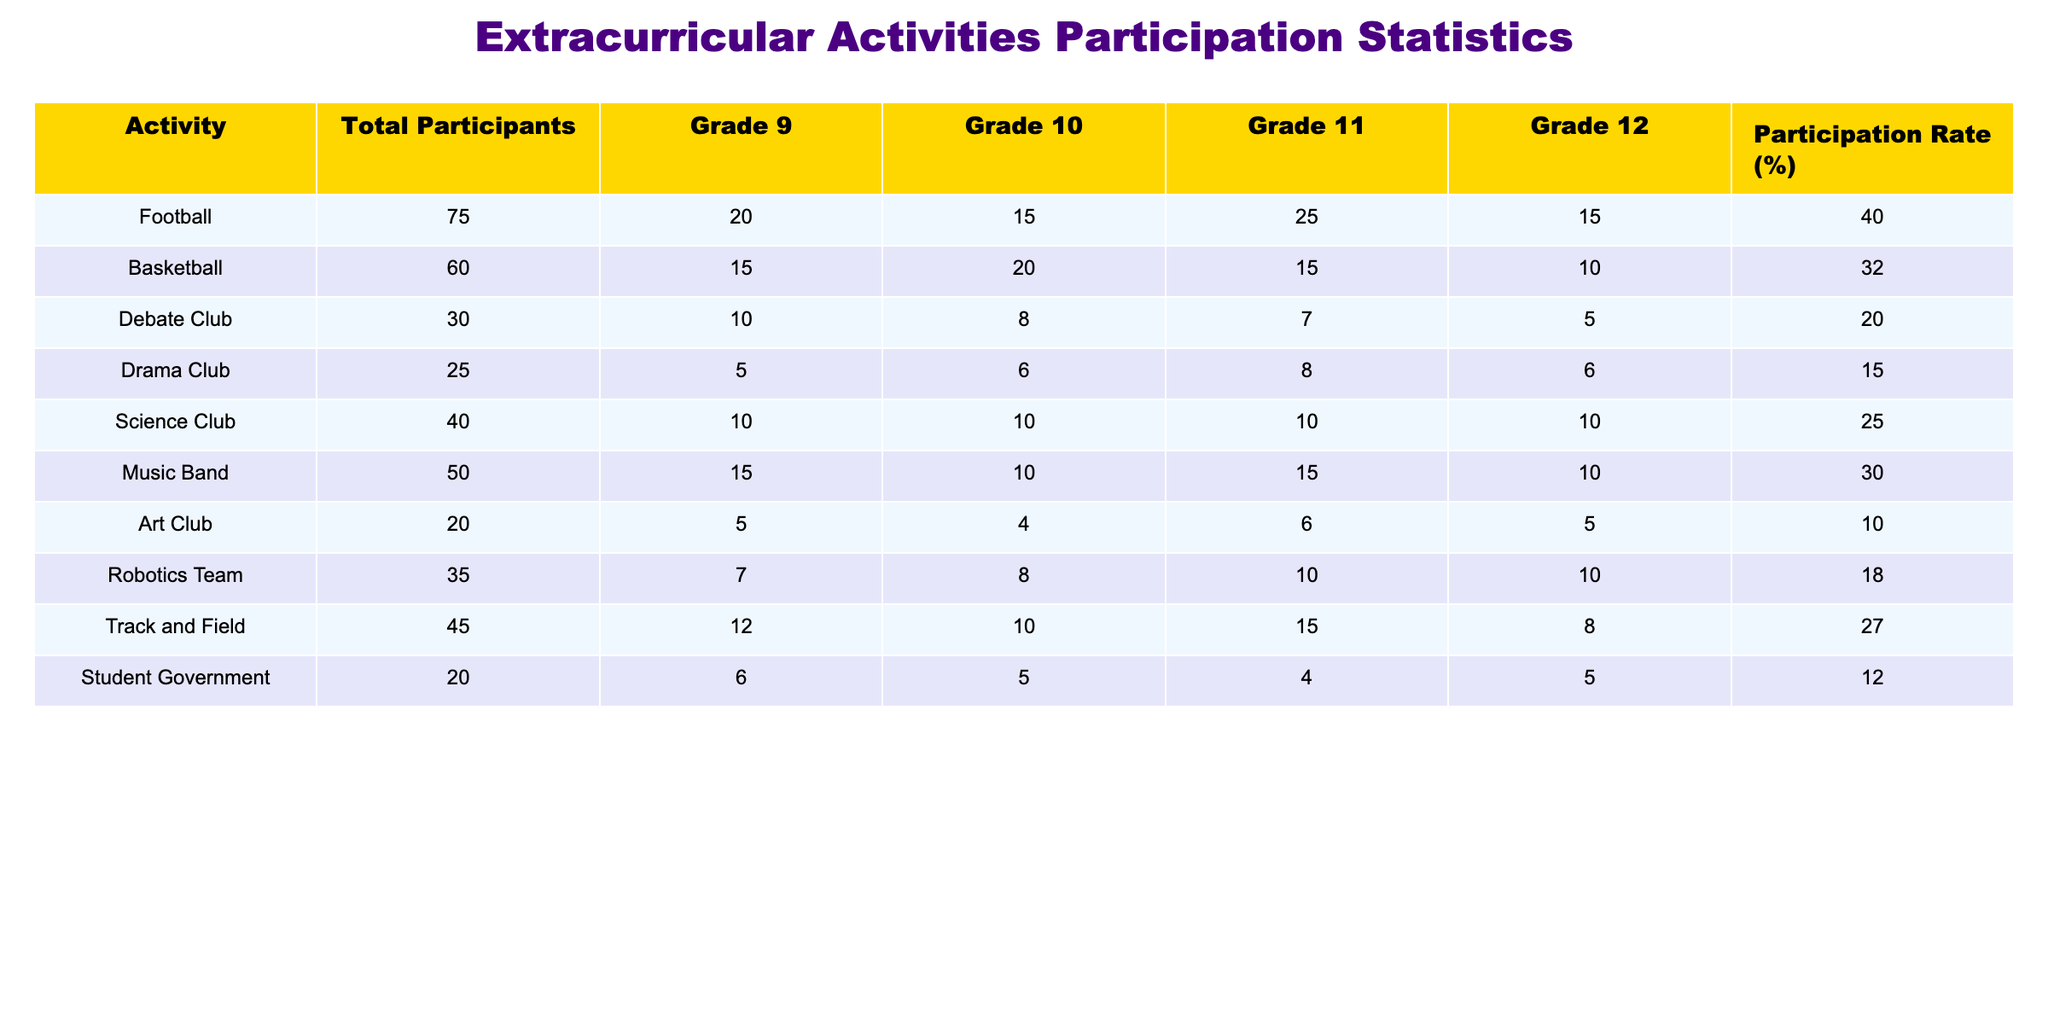What is the total number of participants in the Football activity? From the table, the 'Total Participants' column shows Football has a total of 75 participants.
Answer: 75 Which extracurricular activity has the highest participation rate? By examining the 'Participation Rate (%)' column, Football has a participation rate of 40%, which is the highest compared to other activities.
Answer: Football Calculate the total number of participants from Grades 11 and 12 in the Science Club. For the Science Club, Grade 11 has 10 participants and Grade 12 has 10 participants. Adding these gives 10 + 10 = 20 participants from Grades 11 and 12.
Answer: 20 Is the participation rate for the Debate Club higher than that of the Drama Club? The Debate Club has a participation rate of 20%, while the Drama Club has a participation rate of 15%. Since 20% is greater than 15%, the statement is true.
Answer: Yes What is the average number of participants across all grades for the Music Band? The Music Band has 15 participants from Grade 9, 10 from Grade 10, 15 from Grade 11, and 10 from Grade 12. The average is (15 + 10 + 15 + 10) / 4 = 50 / 4 = 12.5.
Answer: 12.5 How many more participants are there in Football compared to the Art Club? Football has 75 participants, while the Art Club has 20 participants. The difference is 75 - 20 = 55 more participants in Football.
Answer: 55 What percentage of total participants did Track and Field contribute? The total number of participants across all activities is 75 + 60 + 30 + 25 + 40 + 50 + 20 + 35 + 45 + 20 = 410. Track and Field has 45 participants, so the percentage is (45 / 410) * 100 = 10.98%, approximately 11%.
Answer: 11% Which grade has the highest total participation in the Robotics Team? Looking at the Robotics Team, Grade 9 has 7 participants, Grade 10 has 8, Grade 11 has 10, and Grade 12 has 10. Grade 11 and Grade 12 both have the highest participation with 10 participants each.
Answer: Grade 11 and Grade 12 What is the total participation rate for all activities combined? The total participation is the sum of all individual participation numbers divided by the total number of participants across all activities (410). Total participation = (75 + 60 + 30 + 25 + 40 + 50 + 20 + 35 + 45 + 20) = 410. Therefore, the combined participation rate is 100% as it includes all activities.
Answer: 100% 